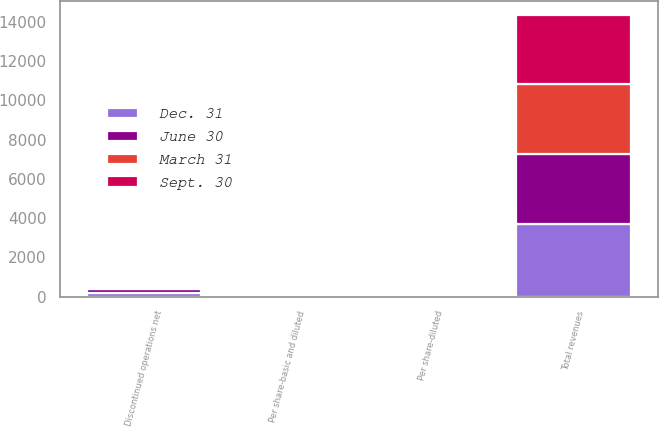Convert chart. <chart><loc_0><loc_0><loc_500><loc_500><stacked_bar_chart><ecel><fcel>Total revenues<fcel>Per share-diluted<fcel>Discontinued operations net<fcel>Per share-basic and diluted<nl><fcel>Sept. 30<fcel>3521<fcel>0.57<fcel>7<fcel>0.02<nl><fcel>March 31<fcel>3523<fcel>0.47<fcel>29<fcel>0.08<nl><fcel>June 30<fcel>3593<fcel>0.79<fcel>187<fcel>0.49<nl><fcel>Dec. 31<fcel>3688<fcel>0.68<fcel>206<fcel>0.53<nl></chart> 